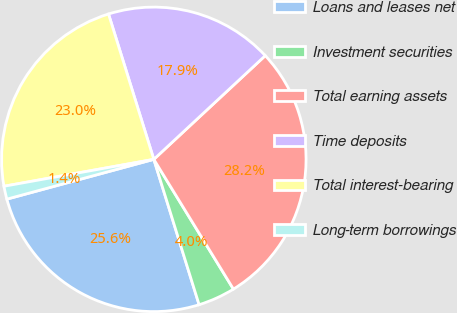<chart> <loc_0><loc_0><loc_500><loc_500><pie_chart><fcel>Loans and leases net<fcel>Investment securities<fcel>Total earning assets<fcel>Time deposits<fcel>Total interest-bearing<fcel>Long-term borrowings<nl><fcel>25.6%<fcel>3.95%<fcel>28.17%<fcel>17.88%<fcel>23.02%<fcel>1.38%<nl></chart> 